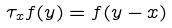<formula> <loc_0><loc_0><loc_500><loc_500>\tau _ { x } f ( y ) = f ( y - x )</formula> 